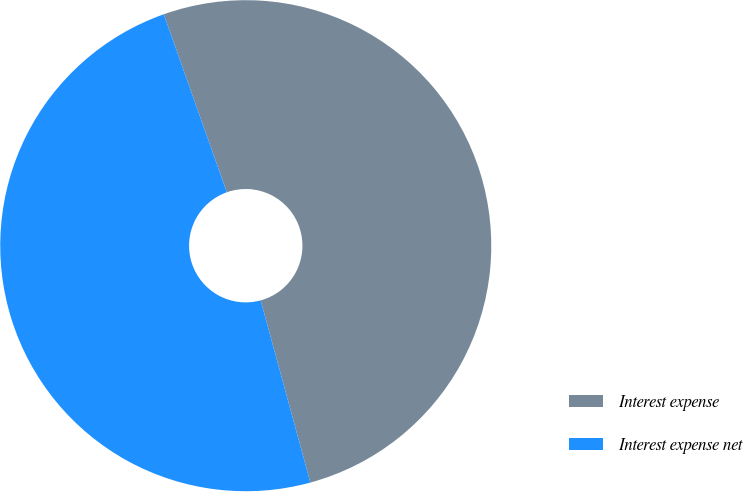<chart> <loc_0><loc_0><loc_500><loc_500><pie_chart><fcel>Interest expense<fcel>Interest expense net<nl><fcel>51.18%<fcel>48.82%<nl></chart> 